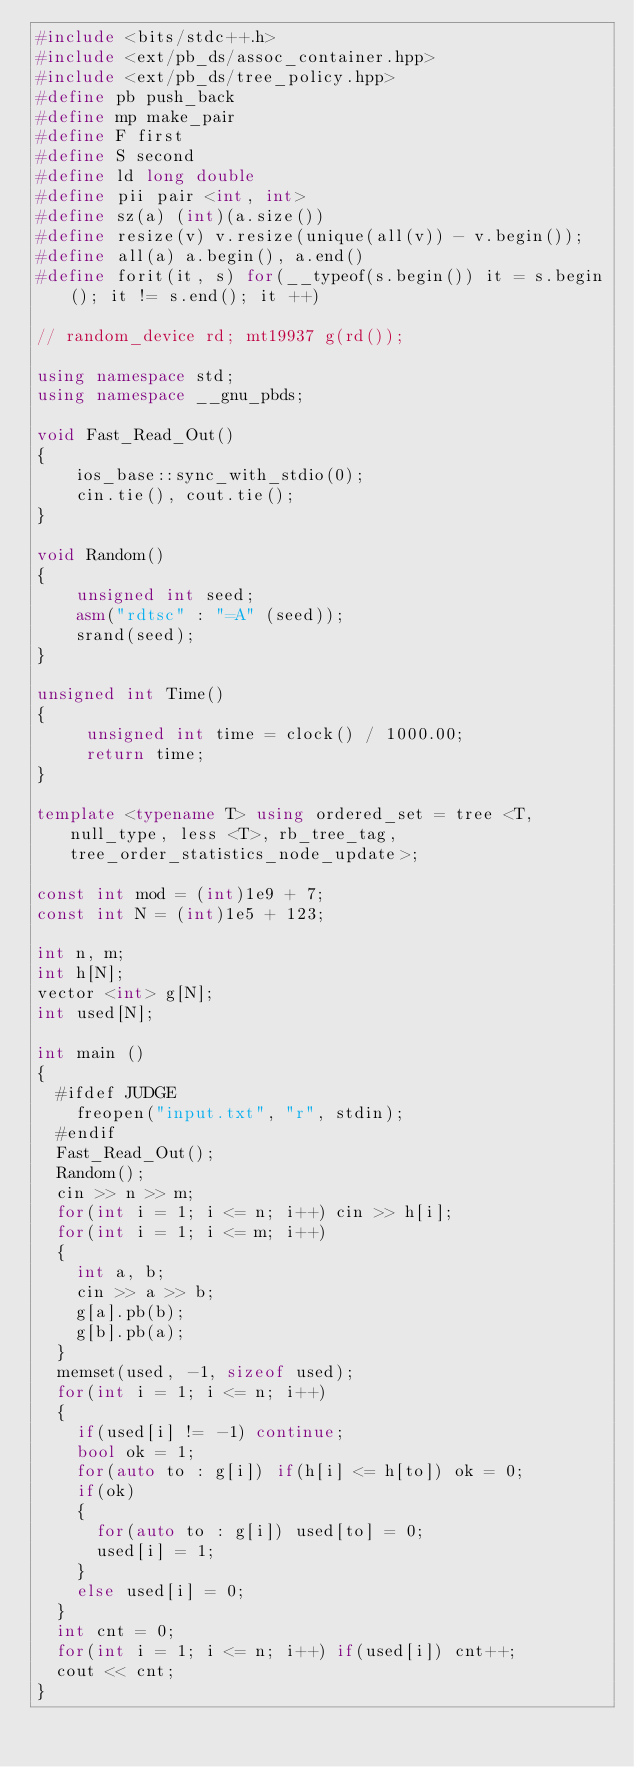Convert code to text. <code><loc_0><loc_0><loc_500><loc_500><_C++_>#include <bits/stdc++.h>	
#include <ext/pb_ds/assoc_container.hpp>
#include <ext/pb_ds/tree_policy.hpp>
#define pb push_back
#define mp make_pair
#define F first
#define S second
#define ld long double
#define pii pair <int, int>
#define sz(a) (int)(a.size()) 
#define resize(v) v.resize(unique(all(v)) - v.begin()); 
#define all(a) a.begin(), a.end()
#define forit(it, s) for(__typeof(s.begin()) it = s.begin(); it != s.end(); it ++)

// random_device rd; mt19937 g(rd());    
                                        	
using namespace std;
using namespace __gnu_pbds;
 
void Fast_Read_Out()
{
    ios_base::sync_with_stdio(0);
    cin.tie(), cout.tie();
}
 
void Random()
{
    unsigned int seed;                                                                        
    asm("rdtsc" : "=A" (seed));
    srand(seed);        
}
 
unsigned int Time()
{
     unsigned int time = clock() / 1000.00;                           
     return time;
}

template <typename T> using ordered_set = tree <T, null_type, less <T>, rb_tree_tag, tree_order_statistics_node_update>; 
 
const int mod = (int)1e9 + 7;
const int N = (int)1e5 + 123;

int n, m;
int h[N];
vector <int> g[N];
int used[N];

int main ()
{
	#ifdef JUDGE
		freopen("input.txt", "r", stdin);
	#endif		
	Fast_Read_Out();
	Random();
	cin >> n >> m;
	for(int i = 1; i <= n; i++) cin >> h[i];
	for(int i = 1; i <= m; i++)
	{
		int a, b;
		cin >> a >> b;
		g[a].pb(b);
		g[b].pb(a);
	}
	memset(used, -1, sizeof used);
	for(int i = 1; i <= n; i++)
	{
		if(used[i] != -1) continue;
		bool ok = 1;
		for(auto to : g[i]) if(h[i] <= h[to]) ok = 0;
		if(ok) 
		{
			for(auto to : g[i]) used[to] = 0;
			used[i] = 1;
		}
		else used[i] = 0;
	}
	int cnt = 0;
	for(int i = 1; i <= n; i++) if(used[i]) cnt++;
	cout << cnt;
}      </code> 